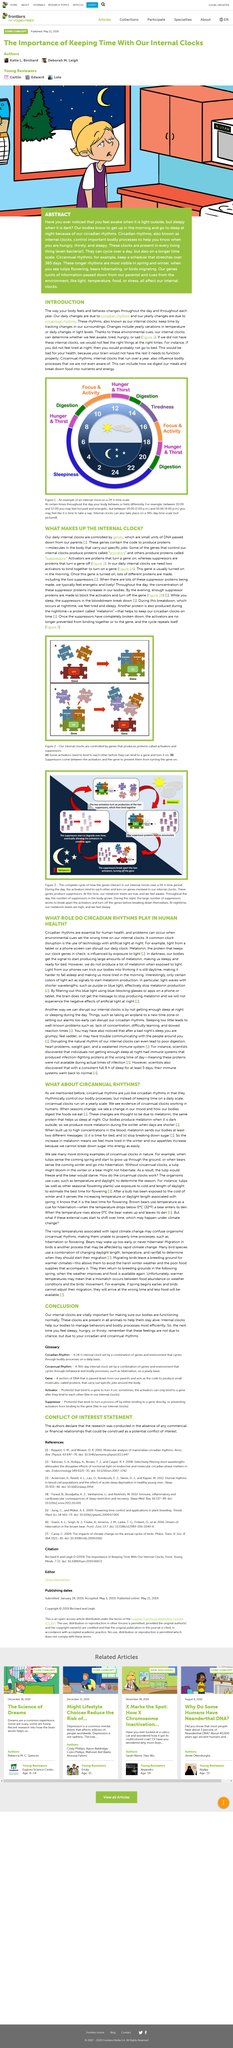Specify some key components in this picture. The suppressors present in the bloodstream are broken down at nighttime. The internal clock is composed of activators and suppressors, which regulate gene expression by turning genes on or off, respectively. Activators are proteins that initiate gene expression, while suppressors are proteins that halt gene expression. In the winter months, the melatonin level in the human body tends to be higher compared to the summer months. Organisms, such as tulips, bears, and birds, are used to illustrate longer rhythms in spring and winter. In Figure 1, between the hours of 2:00 PM and 4:00 PM, you may feel like it is time to take a nap. The image is labeled with "Tiredness" between those specific hours. 